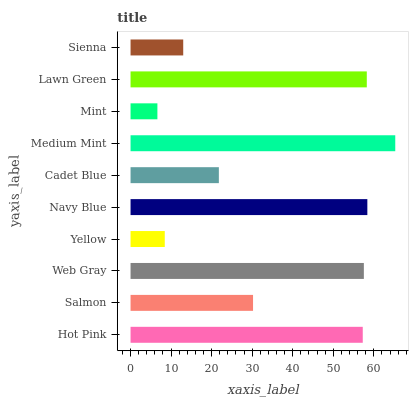Is Mint the minimum?
Answer yes or no. Yes. Is Medium Mint the maximum?
Answer yes or no. Yes. Is Salmon the minimum?
Answer yes or no. No. Is Salmon the maximum?
Answer yes or no. No. Is Hot Pink greater than Salmon?
Answer yes or no. Yes. Is Salmon less than Hot Pink?
Answer yes or no. Yes. Is Salmon greater than Hot Pink?
Answer yes or no. No. Is Hot Pink less than Salmon?
Answer yes or no. No. Is Hot Pink the high median?
Answer yes or no. Yes. Is Salmon the low median?
Answer yes or no. Yes. Is Navy Blue the high median?
Answer yes or no. No. Is Navy Blue the low median?
Answer yes or no. No. 